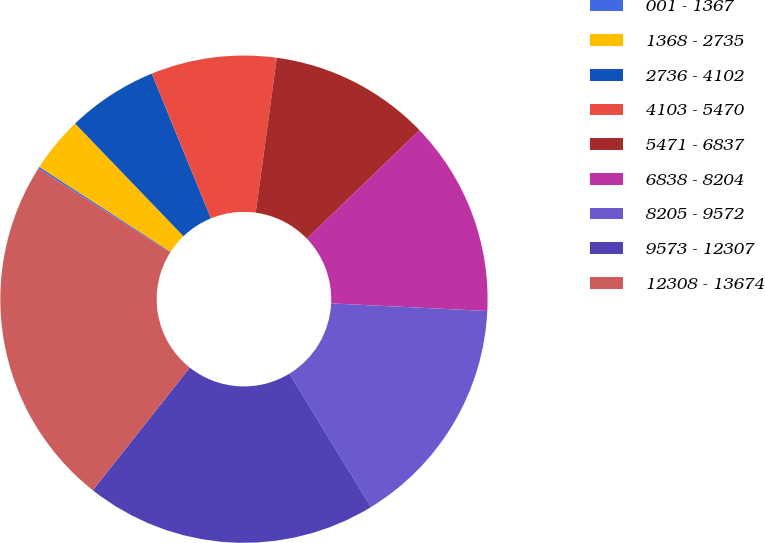Convert chart. <chart><loc_0><loc_0><loc_500><loc_500><pie_chart><fcel>001 - 1367<fcel>1368 - 2735<fcel>2736 - 4102<fcel>4103 - 5470<fcel>5471 - 6837<fcel>6838 - 8204<fcel>8205 - 9572<fcel>9573 - 12307<fcel>12308 - 13674<nl><fcel>0.13%<fcel>3.68%<fcel>6.01%<fcel>8.33%<fcel>10.65%<fcel>12.97%<fcel>15.5%<fcel>19.38%<fcel>23.35%<nl></chart> 